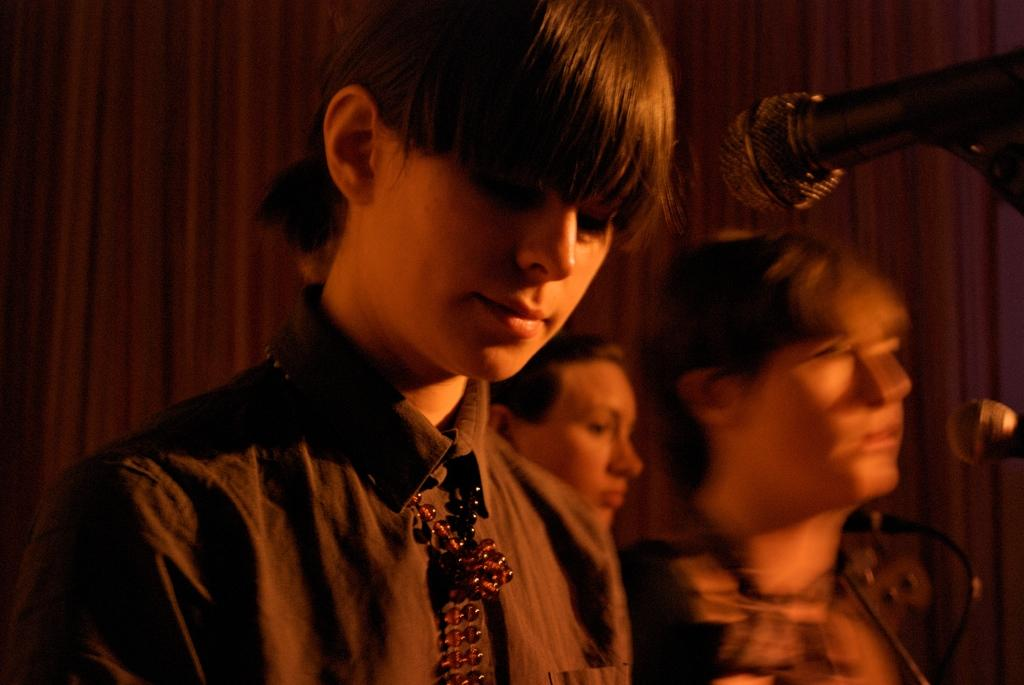How many people are in the group visible in the image? There is a group of people in the image, but the exact number cannot be determined without more specific information. What are the people in the image doing? The people are standing in the image. What objects are in front of the people? There are microphones in front of the people. What type of crate is being used to store the actors' costumes in the image? There is no crate or actors' costumes present in the image. Is there any sleet visible in the image? There is no indication of sleet or any weather conditions in the image. 